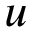<formula> <loc_0><loc_0><loc_500><loc_500>u</formula> 